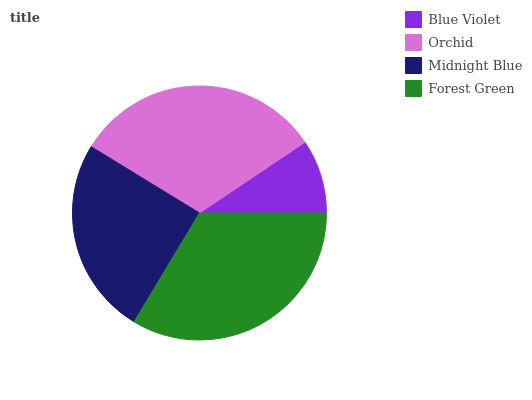Is Blue Violet the minimum?
Answer yes or no. Yes. Is Forest Green the maximum?
Answer yes or no. Yes. Is Orchid the minimum?
Answer yes or no. No. Is Orchid the maximum?
Answer yes or no. No. Is Orchid greater than Blue Violet?
Answer yes or no. Yes. Is Blue Violet less than Orchid?
Answer yes or no. Yes. Is Blue Violet greater than Orchid?
Answer yes or no. No. Is Orchid less than Blue Violet?
Answer yes or no. No. Is Orchid the high median?
Answer yes or no. Yes. Is Midnight Blue the low median?
Answer yes or no. Yes. Is Midnight Blue the high median?
Answer yes or no. No. Is Orchid the low median?
Answer yes or no. No. 